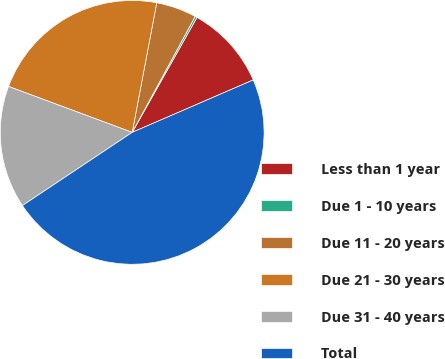Convert chart to OTSL. <chart><loc_0><loc_0><loc_500><loc_500><pie_chart><fcel>Less than 1 year<fcel>Due 1 - 10 years<fcel>Due 11 - 20 years<fcel>Due 21 - 30 years<fcel>Due 31 - 40 years<fcel>Total<nl><fcel>10.33%<fcel>0.25%<fcel>4.94%<fcel>22.32%<fcel>15.02%<fcel>47.15%<nl></chart> 